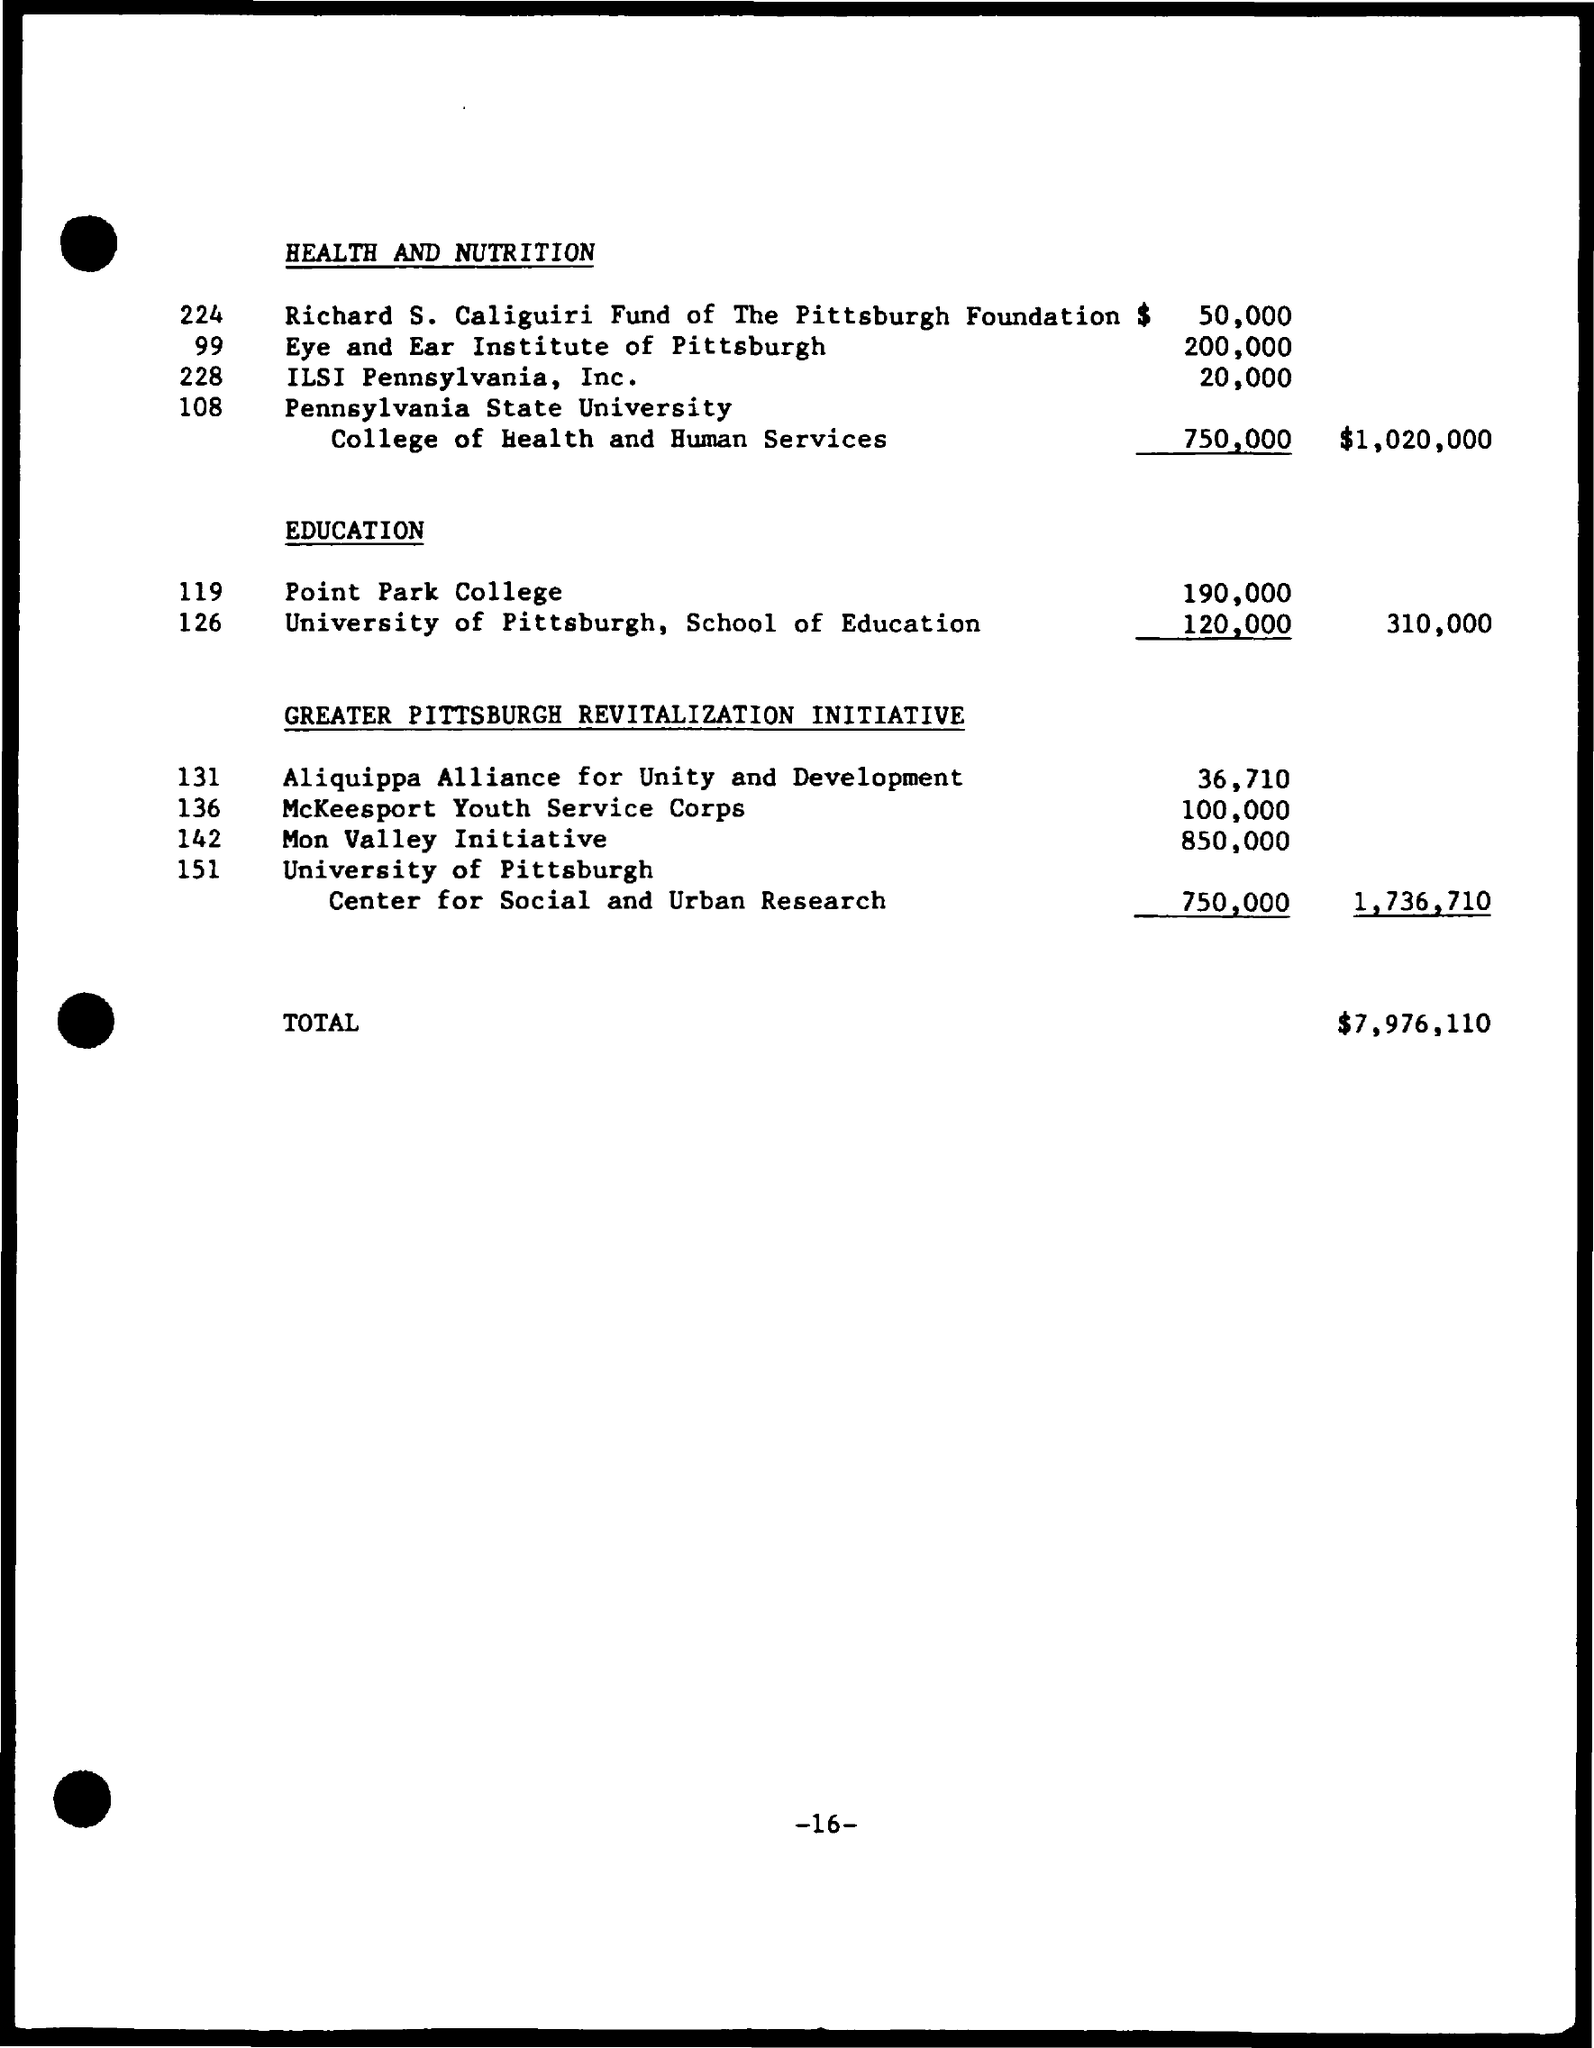Mention a couple of crucial points in this snapshot. The first title in the document is 'HEALTH AND NUTRITION.' The second title in the document is "Education. The total currency amount is $7,976,110. 